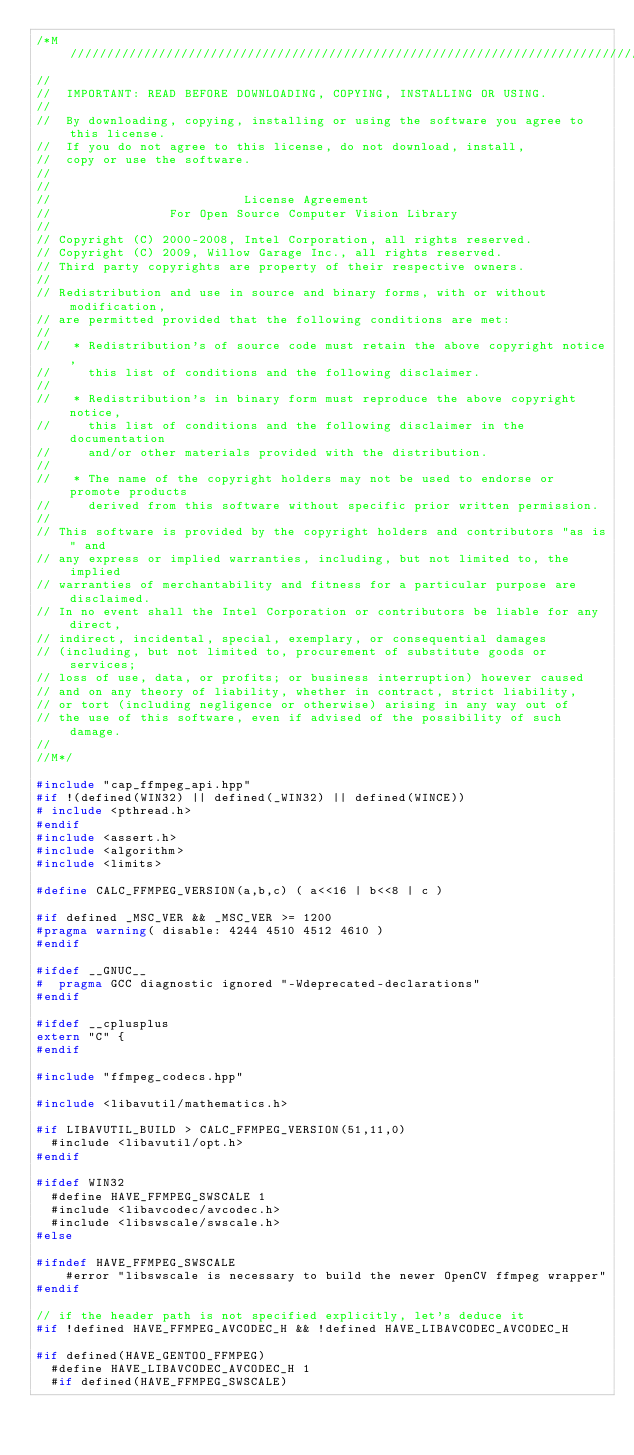Convert code to text. <code><loc_0><loc_0><loc_500><loc_500><_C++_>/*M///////////////////////////////////////////////////////////////////////////////////////
//
//  IMPORTANT: READ BEFORE DOWNLOADING, COPYING, INSTALLING OR USING.
//
//  By downloading, copying, installing or using the software you agree to this license.
//  If you do not agree to this license, do not download, install,
//  copy or use the software.
//
//
//                          License Agreement
//                For Open Source Computer Vision Library
//
// Copyright (C) 2000-2008, Intel Corporation, all rights reserved.
// Copyright (C) 2009, Willow Garage Inc., all rights reserved.
// Third party copyrights are property of their respective owners.
//
// Redistribution and use in source and binary forms, with or without modification,
// are permitted provided that the following conditions are met:
//
//   * Redistribution's of source code must retain the above copyright notice,
//     this list of conditions and the following disclaimer.
//
//   * Redistribution's in binary form must reproduce the above copyright notice,
//     this list of conditions and the following disclaimer in the documentation
//     and/or other materials provided with the distribution.
//
//   * The name of the copyright holders may not be used to endorse or promote products
//     derived from this software without specific prior written permission.
//
// This software is provided by the copyright holders and contributors "as is" and
// any express or implied warranties, including, but not limited to, the implied
// warranties of merchantability and fitness for a particular purpose are disclaimed.
// In no event shall the Intel Corporation or contributors be liable for any direct,
// indirect, incidental, special, exemplary, or consequential damages
// (including, but not limited to, procurement of substitute goods or services;
// loss of use, data, or profits; or business interruption) however caused
// and on any theory of liability, whether in contract, strict liability,
// or tort (including negligence or otherwise) arising in any way out of
// the use of this software, even if advised of the possibility of such damage.
//
//M*/

#include "cap_ffmpeg_api.hpp"
#if !(defined(WIN32) || defined(_WIN32) || defined(WINCE))
# include <pthread.h>
#endif
#include <assert.h>
#include <algorithm>
#include <limits>

#define CALC_FFMPEG_VERSION(a,b,c) ( a<<16 | b<<8 | c )

#if defined _MSC_VER && _MSC_VER >= 1200
#pragma warning( disable: 4244 4510 4512 4610 )
#endif

#ifdef __GNUC__
#  pragma GCC diagnostic ignored "-Wdeprecated-declarations"
#endif

#ifdef __cplusplus
extern "C" {
#endif

#include "ffmpeg_codecs.hpp"

#include <libavutil/mathematics.h>

#if LIBAVUTIL_BUILD > CALC_FFMPEG_VERSION(51,11,0)
  #include <libavutil/opt.h>
#endif

#ifdef WIN32
  #define HAVE_FFMPEG_SWSCALE 1
  #include <libavcodec/avcodec.h>
  #include <libswscale/swscale.h>
#else

#ifndef HAVE_FFMPEG_SWSCALE
    #error "libswscale is necessary to build the newer OpenCV ffmpeg wrapper"
#endif

// if the header path is not specified explicitly, let's deduce it
#if !defined HAVE_FFMPEG_AVCODEC_H && !defined HAVE_LIBAVCODEC_AVCODEC_H

#if defined(HAVE_GENTOO_FFMPEG)
  #define HAVE_LIBAVCODEC_AVCODEC_H 1
  #if defined(HAVE_FFMPEG_SWSCALE)</code> 